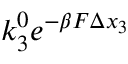<formula> <loc_0><loc_0><loc_500><loc_500>k _ { 3 } ^ { 0 } e ^ { - \beta F \Delta x _ { 3 } }</formula> 